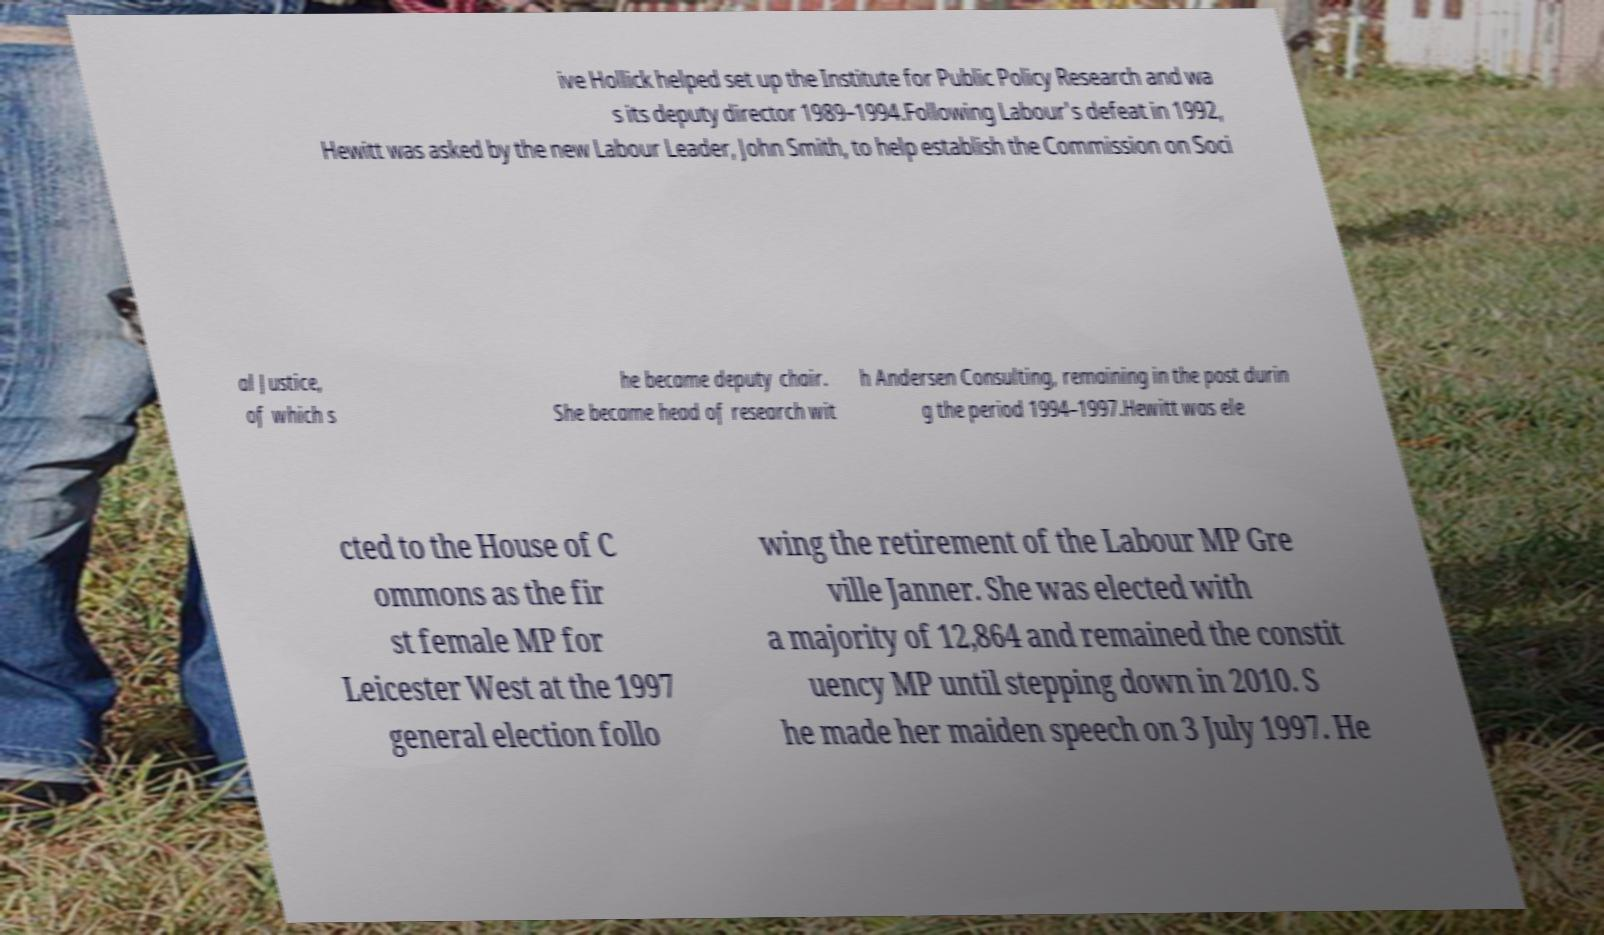I need the written content from this picture converted into text. Can you do that? ive Hollick helped set up the Institute for Public Policy Research and wa s its deputy director 1989–1994.Following Labour's defeat in 1992, Hewitt was asked by the new Labour Leader, John Smith, to help establish the Commission on Soci al Justice, of which s he became deputy chair. She became head of research wit h Andersen Consulting, remaining in the post durin g the period 1994–1997.Hewitt was ele cted to the House of C ommons as the fir st female MP for Leicester West at the 1997 general election follo wing the retirement of the Labour MP Gre ville Janner. She was elected with a majority of 12,864 and remained the constit uency MP until stepping down in 2010. S he made her maiden speech on 3 July 1997. He 